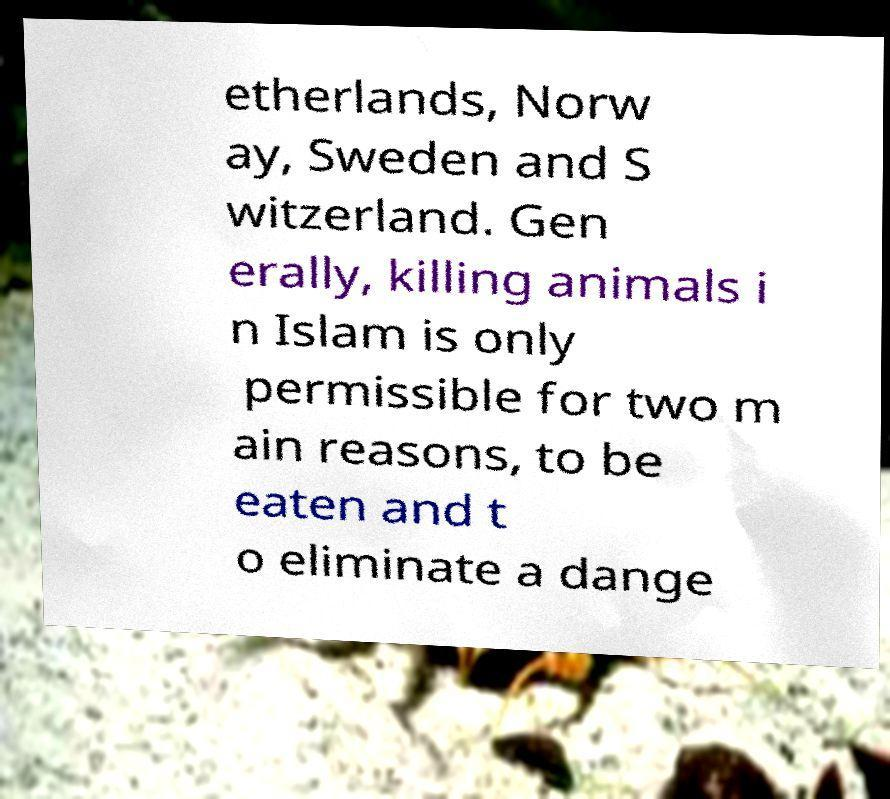Can you read and provide the text displayed in the image?This photo seems to have some interesting text. Can you extract and type it out for me? etherlands, Norw ay, Sweden and S witzerland. Gen erally, killing animals i n Islam is only permissible for two m ain reasons, to be eaten and t o eliminate a dange 